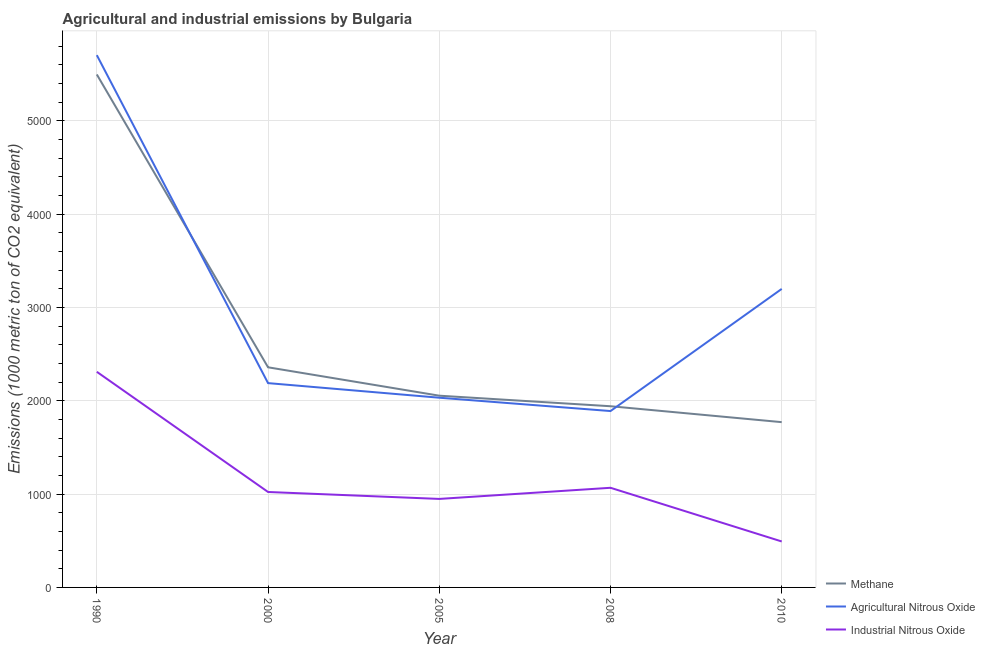How many different coloured lines are there?
Your answer should be compact. 3. Does the line corresponding to amount of industrial nitrous oxide emissions intersect with the line corresponding to amount of methane emissions?
Give a very brief answer. No. Is the number of lines equal to the number of legend labels?
Make the answer very short. Yes. What is the amount of agricultural nitrous oxide emissions in 2000?
Your answer should be compact. 2189.9. Across all years, what is the maximum amount of industrial nitrous oxide emissions?
Provide a succinct answer. 2311.2. Across all years, what is the minimum amount of methane emissions?
Offer a very short reply. 1771.6. What is the total amount of industrial nitrous oxide emissions in the graph?
Give a very brief answer. 5843.4. What is the difference between the amount of methane emissions in 1990 and that in 2000?
Ensure brevity in your answer.  3138.8. What is the difference between the amount of methane emissions in 2010 and the amount of industrial nitrous oxide emissions in 1990?
Ensure brevity in your answer.  -539.6. What is the average amount of agricultural nitrous oxide emissions per year?
Offer a very short reply. 3003.84. In the year 1990, what is the difference between the amount of industrial nitrous oxide emissions and amount of agricultural nitrous oxide emissions?
Your response must be concise. -3394.2. In how many years, is the amount of methane emissions greater than 4400 metric ton?
Your response must be concise. 1. What is the ratio of the amount of methane emissions in 1990 to that in 2008?
Make the answer very short. 2.83. What is the difference between the highest and the second highest amount of industrial nitrous oxide emissions?
Make the answer very short. 1243.2. What is the difference between the highest and the lowest amount of methane emissions?
Provide a short and direct response. 3726.7. Is it the case that in every year, the sum of the amount of methane emissions and amount of agricultural nitrous oxide emissions is greater than the amount of industrial nitrous oxide emissions?
Your response must be concise. Yes. Does the amount of methane emissions monotonically increase over the years?
Your response must be concise. No. Is the amount of agricultural nitrous oxide emissions strictly greater than the amount of industrial nitrous oxide emissions over the years?
Make the answer very short. Yes. How many lines are there?
Your response must be concise. 3. Are the values on the major ticks of Y-axis written in scientific E-notation?
Your answer should be very brief. No. Where does the legend appear in the graph?
Offer a very short reply. Bottom right. What is the title of the graph?
Your answer should be very brief. Agricultural and industrial emissions by Bulgaria. Does "Hydroelectric sources" appear as one of the legend labels in the graph?
Offer a terse response. No. What is the label or title of the X-axis?
Offer a terse response. Year. What is the label or title of the Y-axis?
Keep it short and to the point. Emissions (1000 metric ton of CO2 equivalent). What is the Emissions (1000 metric ton of CO2 equivalent) of Methane in 1990?
Your response must be concise. 5498.3. What is the Emissions (1000 metric ton of CO2 equivalent) of Agricultural Nitrous Oxide in 1990?
Offer a terse response. 5705.4. What is the Emissions (1000 metric ton of CO2 equivalent) of Industrial Nitrous Oxide in 1990?
Your answer should be very brief. 2311.2. What is the Emissions (1000 metric ton of CO2 equivalent) of Methane in 2000?
Offer a terse response. 2359.5. What is the Emissions (1000 metric ton of CO2 equivalent) in Agricultural Nitrous Oxide in 2000?
Ensure brevity in your answer.  2189.9. What is the Emissions (1000 metric ton of CO2 equivalent) of Industrial Nitrous Oxide in 2000?
Your answer should be compact. 1023. What is the Emissions (1000 metric ton of CO2 equivalent) of Methane in 2005?
Your response must be concise. 2055.2. What is the Emissions (1000 metric ton of CO2 equivalent) in Agricultural Nitrous Oxide in 2005?
Offer a terse response. 2033.5. What is the Emissions (1000 metric ton of CO2 equivalent) of Industrial Nitrous Oxide in 2005?
Your response must be concise. 948.6. What is the Emissions (1000 metric ton of CO2 equivalent) of Methane in 2008?
Make the answer very short. 1942.2. What is the Emissions (1000 metric ton of CO2 equivalent) of Agricultural Nitrous Oxide in 2008?
Your answer should be compact. 1890.6. What is the Emissions (1000 metric ton of CO2 equivalent) in Industrial Nitrous Oxide in 2008?
Give a very brief answer. 1068. What is the Emissions (1000 metric ton of CO2 equivalent) in Methane in 2010?
Your answer should be very brief. 1771.6. What is the Emissions (1000 metric ton of CO2 equivalent) of Agricultural Nitrous Oxide in 2010?
Give a very brief answer. 3199.8. What is the Emissions (1000 metric ton of CO2 equivalent) in Industrial Nitrous Oxide in 2010?
Give a very brief answer. 492.6. Across all years, what is the maximum Emissions (1000 metric ton of CO2 equivalent) in Methane?
Your response must be concise. 5498.3. Across all years, what is the maximum Emissions (1000 metric ton of CO2 equivalent) of Agricultural Nitrous Oxide?
Your answer should be compact. 5705.4. Across all years, what is the maximum Emissions (1000 metric ton of CO2 equivalent) of Industrial Nitrous Oxide?
Offer a terse response. 2311.2. Across all years, what is the minimum Emissions (1000 metric ton of CO2 equivalent) in Methane?
Your response must be concise. 1771.6. Across all years, what is the minimum Emissions (1000 metric ton of CO2 equivalent) in Agricultural Nitrous Oxide?
Ensure brevity in your answer.  1890.6. Across all years, what is the minimum Emissions (1000 metric ton of CO2 equivalent) of Industrial Nitrous Oxide?
Provide a succinct answer. 492.6. What is the total Emissions (1000 metric ton of CO2 equivalent) of Methane in the graph?
Keep it short and to the point. 1.36e+04. What is the total Emissions (1000 metric ton of CO2 equivalent) of Agricultural Nitrous Oxide in the graph?
Offer a terse response. 1.50e+04. What is the total Emissions (1000 metric ton of CO2 equivalent) in Industrial Nitrous Oxide in the graph?
Make the answer very short. 5843.4. What is the difference between the Emissions (1000 metric ton of CO2 equivalent) in Methane in 1990 and that in 2000?
Provide a succinct answer. 3138.8. What is the difference between the Emissions (1000 metric ton of CO2 equivalent) in Agricultural Nitrous Oxide in 1990 and that in 2000?
Ensure brevity in your answer.  3515.5. What is the difference between the Emissions (1000 metric ton of CO2 equivalent) in Industrial Nitrous Oxide in 1990 and that in 2000?
Make the answer very short. 1288.2. What is the difference between the Emissions (1000 metric ton of CO2 equivalent) of Methane in 1990 and that in 2005?
Keep it short and to the point. 3443.1. What is the difference between the Emissions (1000 metric ton of CO2 equivalent) of Agricultural Nitrous Oxide in 1990 and that in 2005?
Give a very brief answer. 3671.9. What is the difference between the Emissions (1000 metric ton of CO2 equivalent) of Industrial Nitrous Oxide in 1990 and that in 2005?
Offer a terse response. 1362.6. What is the difference between the Emissions (1000 metric ton of CO2 equivalent) of Methane in 1990 and that in 2008?
Keep it short and to the point. 3556.1. What is the difference between the Emissions (1000 metric ton of CO2 equivalent) in Agricultural Nitrous Oxide in 1990 and that in 2008?
Offer a terse response. 3814.8. What is the difference between the Emissions (1000 metric ton of CO2 equivalent) in Industrial Nitrous Oxide in 1990 and that in 2008?
Your response must be concise. 1243.2. What is the difference between the Emissions (1000 metric ton of CO2 equivalent) in Methane in 1990 and that in 2010?
Your answer should be compact. 3726.7. What is the difference between the Emissions (1000 metric ton of CO2 equivalent) in Agricultural Nitrous Oxide in 1990 and that in 2010?
Offer a terse response. 2505.6. What is the difference between the Emissions (1000 metric ton of CO2 equivalent) of Industrial Nitrous Oxide in 1990 and that in 2010?
Your response must be concise. 1818.6. What is the difference between the Emissions (1000 metric ton of CO2 equivalent) in Methane in 2000 and that in 2005?
Ensure brevity in your answer.  304.3. What is the difference between the Emissions (1000 metric ton of CO2 equivalent) in Agricultural Nitrous Oxide in 2000 and that in 2005?
Offer a terse response. 156.4. What is the difference between the Emissions (1000 metric ton of CO2 equivalent) in Industrial Nitrous Oxide in 2000 and that in 2005?
Make the answer very short. 74.4. What is the difference between the Emissions (1000 metric ton of CO2 equivalent) of Methane in 2000 and that in 2008?
Provide a succinct answer. 417.3. What is the difference between the Emissions (1000 metric ton of CO2 equivalent) of Agricultural Nitrous Oxide in 2000 and that in 2008?
Offer a terse response. 299.3. What is the difference between the Emissions (1000 metric ton of CO2 equivalent) in Industrial Nitrous Oxide in 2000 and that in 2008?
Make the answer very short. -45. What is the difference between the Emissions (1000 metric ton of CO2 equivalent) in Methane in 2000 and that in 2010?
Offer a terse response. 587.9. What is the difference between the Emissions (1000 metric ton of CO2 equivalent) of Agricultural Nitrous Oxide in 2000 and that in 2010?
Give a very brief answer. -1009.9. What is the difference between the Emissions (1000 metric ton of CO2 equivalent) of Industrial Nitrous Oxide in 2000 and that in 2010?
Offer a terse response. 530.4. What is the difference between the Emissions (1000 metric ton of CO2 equivalent) in Methane in 2005 and that in 2008?
Your answer should be very brief. 113. What is the difference between the Emissions (1000 metric ton of CO2 equivalent) in Agricultural Nitrous Oxide in 2005 and that in 2008?
Provide a short and direct response. 142.9. What is the difference between the Emissions (1000 metric ton of CO2 equivalent) of Industrial Nitrous Oxide in 2005 and that in 2008?
Make the answer very short. -119.4. What is the difference between the Emissions (1000 metric ton of CO2 equivalent) in Methane in 2005 and that in 2010?
Make the answer very short. 283.6. What is the difference between the Emissions (1000 metric ton of CO2 equivalent) in Agricultural Nitrous Oxide in 2005 and that in 2010?
Keep it short and to the point. -1166.3. What is the difference between the Emissions (1000 metric ton of CO2 equivalent) in Industrial Nitrous Oxide in 2005 and that in 2010?
Your answer should be compact. 456. What is the difference between the Emissions (1000 metric ton of CO2 equivalent) of Methane in 2008 and that in 2010?
Your answer should be very brief. 170.6. What is the difference between the Emissions (1000 metric ton of CO2 equivalent) of Agricultural Nitrous Oxide in 2008 and that in 2010?
Your answer should be compact. -1309.2. What is the difference between the Emissions (1000 metric ton of CO2 equivalent) in Industrial Nitrous Oxide in 2008 and that in 2010?
Offer a terse response. 575.4. What is the difference between the Emissions (1000 metric ton of CO2 equivalent) of Methane in 1990 and the Emissions (1000 metric ton of CO2 equivalent) of Agricultural Nitrous Oxide in 2000?
Provide a succinct answer. 3308.4. What is the difference between the Emissions (1000 metric ton of CO2 equivalent) in Methane in 1990 and the Emissions (1000 metric ton of CO2 equivalent) in Industrial Nitrous Oxide in 2000?
Your response must be concise. 4475.3. What is the difference between the Emissions (1000 metric ton of CO2 equivalent) of Agricultural Nitrous Oxide in 1990 and the Emissions (1000 metric ton of CO2 equivalent) of Industrial Nitrous Oxide in 2000?
Your answer should be compact. 4682.4. What is the difference between the Emissions (1000 metric ton of CO2 equivalent) in Methane in 1990 and the Emissions (1000 metric ton of CO2 equivalent) in Agricultural Nitrous Oxide in 2005?
Keep it short and to the point. 3464.8. What is the difference between the Emissions (1000 metric ton of CO2 equivalent) in Methane in 1990 and the Emissions (1000 metric ton of CO2 equivalent) in Industrial Nitrous Oxide in 2005?
Ensure brevity in your answer.  4549.7. What is the difference between the Emissions (1000 metric ton of CO2 equivalent) of Agricultural Nitrous Oxide in 1990 and the Emissions (1000 metric ton of CO2 equivalent) of Industrial Nitrous Oxide in 2005?
Your answer should be compact. 4756.8. What is the difference between the Emissions (1000 metric ton of CO2 equivalent) in Methane in 1990 and the Emissions (1000 metric ton of CO2 equivalent) in Agricultural Nitrous Oxide in 2008?
Give a very brief answer. 3607.7. What is the difference between the Emissions (1000 metric ton of CO2 equivalent) in Methane in 1990 and the Emissions (1000 metric ton of CO2 equivalent) in Industrial Nitrous Oxide in 2008?
Your answer should be compact. 4430.3. What is the difference between the Emissions (1000 metric ton of CO2 equivalent) of Agricultural Nitrous Oxide in 1990 and the Emissions (1000 metric ton of CO2 equivalent) of Industrial Nitrous Oxide in 2008?
Offer a very short reply. 4637.4. What is the difference between the Emissions (1000 metric ton of CO2 equivalent) in Methane in 1990 and the Emissions (1000 metric ton of CO2 equivalent) in Agricultural Nitrous Oxide in 2010?
Your answer should be compact. 2298.5. What is the difference between the Emissions (1000 metric ton of CO2 equivalent) of Methane in 1990 and the Emissions (1000 metric ton of CO2 equivalent) of Industrial Nitrous Oxide in 2010?
Provide a short and direct response. 5005.7. What is the difference between the Emissions (1000 metric ton of CO2 equivalent) in Agricultural Nitrous Oxide in 1990 and the Emissions (1000 metric ton of CO2 equivalent) in Industrial Nitrous Oxide in 2010?
Provide a succinct answer. 5212.8. What is the difference between the Emissions (1000 metric ton of CO2 equivalent) of Methane in 2000 and the Emissions (1000 metric ton of CO2 equivalent) of Agricultural Nitrous Oxide in 2005?
Provide a succinct answer. 326. What is the difference between the Emissions (1000 metric ton of CO2 equivalent) of Methane in 2000 and the Emissions (1000 metric ton of CO2 equivalent) of Industrial Nitrous Oxide in 2005?
Your answer should be compact. 1410.9. What is the difference between the Emissions (1000 metric ton of CO2 equivalent) in Agricultural Nitrous Oxide in 2000 and the Emissions (1000 metric ton of CO2 equivalent) in Industrial Nitrous Oxide in 2005?
Offer a very short reply. 1241.3. What is the difference between the Emissions (1000 metric ton of CO2 equivalent) in Methane in 2000 and the Emissions (1000 metric ton of CO2 equivalent) in Agricultural Nitrous Oxide in 2008?
Your response must be concise. 468.9. What is the difference between the Emissions (1000 metric ton of CO2 equivalent) in Methane in 2000 and the Emissions (1000 metric ton of CO2 equivalent) in Industrial Nitrous Oxide in 2008?
Your response must be concise. 1291.5. What is the difference between the Emissions (1000 metric ton of CO2 equivalent) of Agricultural Nitrous Oxide in 2000 and the Emissions (1000 metric ton of CO2 equivalent) of Industrial Nitrous Oxide in 2008?
Offer a very short reply. 1121.9. What is the difference between the Emissions (1000 metric ton of CO2 equivalent) of Methane in 2000 and the Emissions (1000 metric ton of CO2 equivalent) of Agricultural Nitrous Oxide in 2010?
Your answer should be compact. -840.3. What is the difference between the Emissions (1000 metric ton of CO2 equivalent) of Methane in 2000 and the Emissions (1000 metric ton of CO2 equivalent) of Industrial Nitrous Oxide in 2010?
Your response must be concise. 1866.9. What is the difference between the Emissions (1000 metric ton of CO2 equivalent) of Agricultural Nitrous Oxide in 2000 and the Emissions (1000 metric ton of CO2 equivalent) of Industrial Nitrous Oxide in 2010?
Your answer should be very brief. 1697.3. What is the difference between the Emissions (1000 metric ton of CO2 equivalent) in Methane in 2005 and the Emissions (1000 metric ton of CO2 equivalent) in Agricultural Nitrous Oxide in 2008?
Keep it short and to the point. 164.6. What is the difference between the Emissions (1000 metric ton of CO2 equivalent) in Methane in 2005 and the Emissions (1000 metric ton of CO2 equivalent) in Industrial Nitrous Oxide in 2008?
Keep it short and to the point. 987.2. What is the difference between the Emissions (1000 metric ton of CO2 equivalent) of Agricultural Nitrous Oxide in 2005 and the Emissions (1000 metric ton of CO2 equivalent) of Industrial Nitrous Oxide in 2008?
Make the answer very short. 965.5. What is the difference between the Emissions (1000 metric ton of CO2 equivalent) in Methane in 2005 and the Emissions (1000 metric ton of CO2 equivalent) in Agricultural Nitrous Oxide in 2010?
Give a very brief answer. -1144.6. What is the difference between the Emissions (1000 metric ton of CO2 equivalent) of Methane in 2005 and the Emissions (1000 metric ton of CO2 equivalent) of Industrial Nitrous Oxide in 2010?
Make the answer very short. 1562.6. What is the difference between the Emissions (1000 metric ton of CO2 equivalent) in Agricultural Nitrous Oxide in 2005 and the Emissions (1000 metric ton of CO2 equivalent) in Industrial Nitrous Oxide in 2010?
Offer a very short reply. 1540.9. What is the difference between the Emissions (1000 metric ton of CO2 equivalent) in Methane in 2008 and the Emissions (1000 metric ton of CO2 equivalent) in Agricultural Nitrous Oxide in 2010?
Provide a succinct answer. -1257.6. What is the difference between the Emissions (1000 metric ton of CO2 equivalent) of Methane in 2008 and the Emissions (1000 metric ton of CO2 equivalent) of Industrial Nitrous Oxide in 2010?
Your response must be concise. 1449.6. What is the difference between the Emissions (1000 metric ton of CO2 equivalent) in Agricultural Nitrous Oxide in 2008 and the Emissions (1000 metric ton of CO2 equivalent) in Industrial Nitrous Oxide in 2010?
Keep it short and to the point. 1398. What is the average Emissions (1000 metric ton of CO2 equivalent) in Methane per year?
Provide a succinct answer. 2725.36. What is the average Emissions (1000 metric ton of CO2 equivalent) of Agricultural Nitrous Oxide per year?
Provide a short and direct response. 3003.84. What is the average Emissions (1000 metric ton of CO2 equivalent) of Industrial Nitrous Oxide per year?
Your answer should be compact. 1168.68. In the year 1990, what is the difference between the Emissions (1000 metric ton of CO2 equivalent) in Methane and Emissions (1000 metric ton of CO2 equivalent) in Agricultural Nitrous Oxide?
Offer a terse response. -207.1. In the year 1990, what is the difference between the Emissions (1000 metric ton of CO2 equivalent) of Methane and Emissions (1000 metric ton of CO2 equivalent) of Industrial Nitrous Oxide?
Ensure brevity in your answer.  3187.1. In the year 1990, what is the difference between the Emissions (1000 metric ton of CO2 equivalent) in Agricultural Nitrous Oxide and Emissions (1000 metric ton of CO2 equivalent) in Industrial Nitrous Oxide?
Offer a very short reply. 3394.2. In the year 2000, what is the difference between the Emissions (1000 metric ton of CO2 equivalent) in Methane and Emissions (1000 metric ton of CO2 equivalent) in Agricultural Nitrous Oxide?
Ensure brevity in your answer.  169.6. In the year 2000, what is the difference between the Emissions (1000 metric ton of CO2 equivalent) in Methane and Emissions (1000 metric ton of CO2 equivalent) in Industrial Nitrous Oxide?
Ensure brevity in your answer.  1336.5. In the year 2000, what is the difference between the Emissions (1000 metric ton of CO2 equivalent) of Agricultural Nitrous Oxide and Emissions (1000 metric ton of CO2 equivalent) of Industrial Nitrous Oxide?
Make the answer very short. 1166.9. In the year 2005, what is the difference between the Emissions (1000 metric ton of CO2 equivalent) in Methane and Emissions (1000 metric ton of CO2 equivalent) in Agricultural Nitrous Oxide?
Ensure brevity in your answer.  21.7. In the year 2005, what is the difference between the Emissions (1000 metric ton of CO2 equivalent) of Methane and Emissions (1000 metric ton of CO2 equivalent) of Industrial Nitrous Oxide?
Offer a very short reply. 1106.6. In the year 2005, what is the difference between the Emissions (1000 metric ton of CO2 equivalent) in Agricultural Nitrous Oxide and Emissions (1000 metric ton of CO2 equivalent) in Industrial Nitrous Oxide?
Ensure brevity in your answer.  1084.9. In the year 2008, what is the difference between the Emissions (1000 metric ton of CO2 equivalent) in Methane and Emissions (1000 metric ton of CO2 equivalent) in Agricultural Nitrous Oxide?
Provide a succinct answer. 51.6. In the year 2008, what is the difference between the Emissions (1000 metric ton of CO2 equivalent) of Methane and Emissions (1000 metric ton of CO2 equivalent) of Industrial Nitrous Oxide?
Offer a terse response. 874.2. In the year 2008, what is the difference between the Emissions (1000 metric ton of CO2 equivalent) of Agricultural Nitrous Oxide and Emissions (1000 metric ton of CO2 equivalent) of Industrial Nitrous Oxide?
Make the answer very short. 822.6. In the year 2010, what is the difference between the Emissions (1000 metric ton of CO2 equivalent) of Methane and Emissions (1000 metric ton of CO2 equivalent) of Agricultural Nitrous Oxide?
Provide a short and direct response. -1428.2. In the year 2010, what is the difference between the Emissions (1000 metric ton of CO2 equivalent) in Methane and Emissions (1000 metric ton of CO2 equivalent) in Industrial Nitrous Oxide?
Offer a terse response. 1279. In the year 2010, what is the difference between the Emissions (1000 metric ton of CO2 equivalent) in Agricultural Nitrous Oxide and Emissions (1000 metric ton of CO2 equivalent) in Industrial Nitrous Oxide?
Ensure brevity in your answer.  2707.2. What is the ratio of the Emissions (1000 metric ton of CO2 equivalent) of Methane in 1990 to that in 2000?
Your response must be concise. 2.33. What is the ratio of the Emissions (1000 metric ton of CO2 equivalent) of Agricultural Nitrous Oxide in 1990 to that in 2000?
Make the answer very short. 2.61. What is the ratio of the Emissions (1000 metric ton of CO2 equivalent) in Industrial Nitrous Oxide in 1990 to that in 2000?
Make the answer very short. 2.26. What is the ratio of the Emissions (1000 metric ton of CO2 equivalent) in Methane in 1990 to that in 2005?
Your response must be concise. 2.68. What is the ratio of the Emissions (1000 metric ton of CO2 equivalent) in Agricultural Nitrous Oxide in 1990 to that in 2005?
Offer a terse response. 2.81. What is the ratio of the Emissions (1000 metric ton of CO2 equivalent) in Industrial Nitrous Oxide in 1990 to that in 2005?
Offer a very short reply. 2.44. What is the ratio of the Emissions (1000 metric ton of CO2 equivalent) in Methane in 1990 to that in 2008?
Provide a short and direct response. 2.83. What is the ratio of the Emissions (1000 metric ton of CO2 equivalent) of Agricultural Nitrous Oxide in 1990 to that in 2008?
Offer a very short reply. 3.02. What is the ratio of the Emissions (1000 metric ton of CO2 equivalent) in Industrial Nitrous Oxide in 1990 to that in 2008?
Give a very brief answer. 2.16. What is the ratio of the Emissions (1000 metric ton of CO2 equivalent) in Methane in 1990 to that in 2010?
Your answer should be very brief. 3.1. What is the ratio of the Emissions (1000 metric ton of CO2 equivalent) in Agricultural Nitrous Oxide in 1990 to that in 2010?
Offer a terse response. 1.78. What is the ratio of the Emissions (1000 metric ton of CO2 equivalent) of Industrial Nitrous Oxide in 1990 to that in 2010?
Offer a terse response. 4.69. What is the ratio of the Emissions (1000 metric ton of CO2 equivalent) of Methane in 2000 to that in 2005?
Provide a short and direct response. 1.15. What is the ratio of the Emissions (1000 metric ton of CO2 equivalent) in Industrial Nitrous Oxide in 2000 to that in 2005?
Provide a succinct answer. 1.08. What is the ratio of the Emissions (1000 metric ton of CO2 equivalent) in Methane in 2000 to that in 2008?
Keep it short and to the point. 1.21. What is the ratio of the Emissions (1000 metric ton of CO2 equivalent) in Agricultural Nitrous Oxide in 2000 to that in 2008?
Make the answer very short. 1.16. What is the ratio of the Emissions (1000 metric ton of CO2 equivalent) of Industrial Nitrous Oxide in 2000 to that in 2008?
Make the answer very short. 0.96. What is the ratio of the Emissions (1000 metric ton of CO2 equivalent) in Methane in 2000 to that in 2010?
Provide a succinct answer. 1.33. What is the ratio of the Emissions (1000 metric ton of CO2 equivalent) of Agricultural Nitrous Oxide in 2000 to that in 2010?
Your answer should be compact. 0.68. What is the ratio of the Emissions (1000 metric ton of CO2 equivalent) of Industrial Nitrous Oxide in 2000 to that in 2010?
Ensure brevity in your answer.  2.08. What is the ratio of the Emissions (1000 metric ton of CO2 equivalent) in Methane in 2005 to that in 2008?
Your answer should be very brief. 1.06. What is the ratio of the Emissions (1000 metric ton of CO2 equivalent) in Agricultural Nitrous Oxide in 2005 to that in 2008?
Offer a terse response. 1.08. What is the ratio of the Emissions (1000 metric ton of CO2 equivalent) in Industrial Nitrous Oxide in 2005 to that in 2008?
Your answer should be very brief. 0.89. What is the ratio of the Emissions (1000 metric ton of CO2 equivalent) of Methane in 2005 to that in 2010?
Your answer should be compact. 1.16. What is the ratio of the Emissions (1000 metric ton of CO2 equivalent) of Agricultural Nitrous Oxide in 2005 to that in 2010?
Keep it short and to the point. 0.64. What is the ratio of the Emissions (1000 metric ton of CO2 equivalent) in Industrial Nitrous Oxide in 2005 to that in 2010?
Provide a short and direct response. 1.93. What is the ratio of the Emissions (1000 metric ton of CO2 equivalent) in Methane in 2008 to that in 2010?
Offer a terse response. 1.1. What is the ratio of the Emissions (1000 metric ton of CO2 equivalent) of Agricultural Nitrous Oxide in 2008 to that in 2010?
Offer a terse response. 0.59. What is the ratio of the Emissions (1000 metric ton of CO2 equivalent) in Industrial Nitrous Oxide in 2008 to that in 2010?
Provide a short and direct response. 2.17. What is the difference between the highest and the second highest Emissions (1000 metric ton of CO2 equivalent) in Methane?
Keep it short and to the point. 3138.8. What is the difference between the highest and the second highest Emissions (1000 metric ton of CO2 equivalent) of Agricultural Nitrous Oxide?
Your response must be concise. 2505.6. What is the difference between the highest and the second highest Emissions (1000 metric ton of CO2 equivalent) in Industrial Nitrous Oxide?
Your answer should be very brief. 1243.2. What is the difference between the highest and the lowest Emissions (1000 metric ton of CO2 equivalent) of Methane?
Your answer should be very brief. 3726.7. What is the difference between the highest and the lowest Emissions (1000 metric ton of CO2 equivalent) of Agricultural Nitrous Oxide?
Keep it short and to the point. 3814.8. What is the difference between the highest and the lowest Emissions (1000 metric ton of CO2 equivalent) in Industrial Nitrous Oxide?
Keep it short and to the point. 1818.6. 